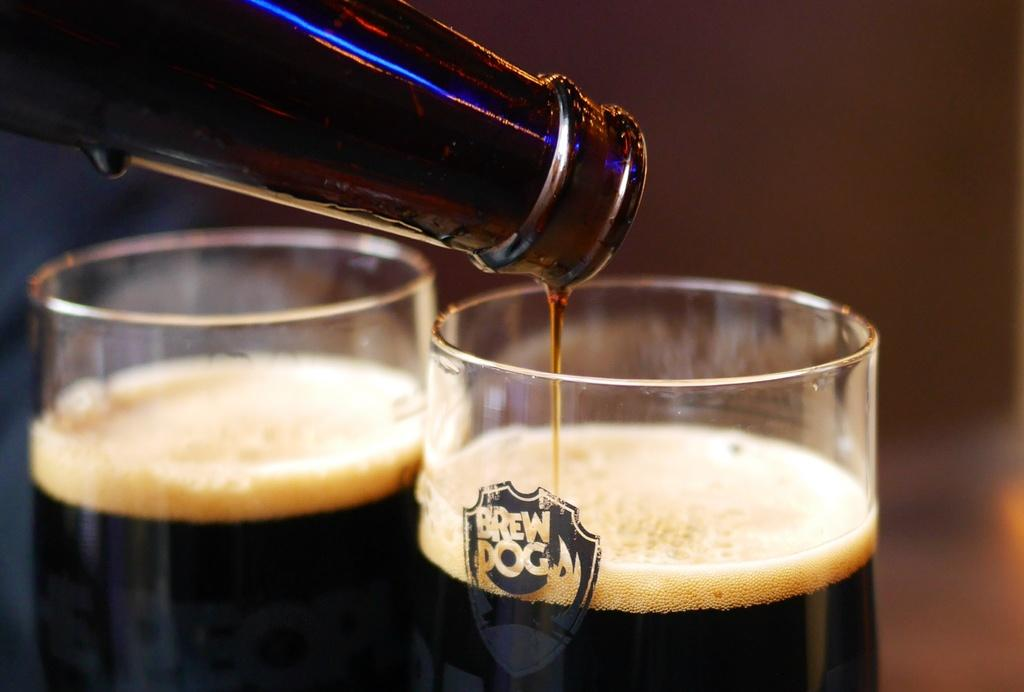Provide a one-sentence caption for the provided image. Two glasses one that says Brew dog sitting on a table. 